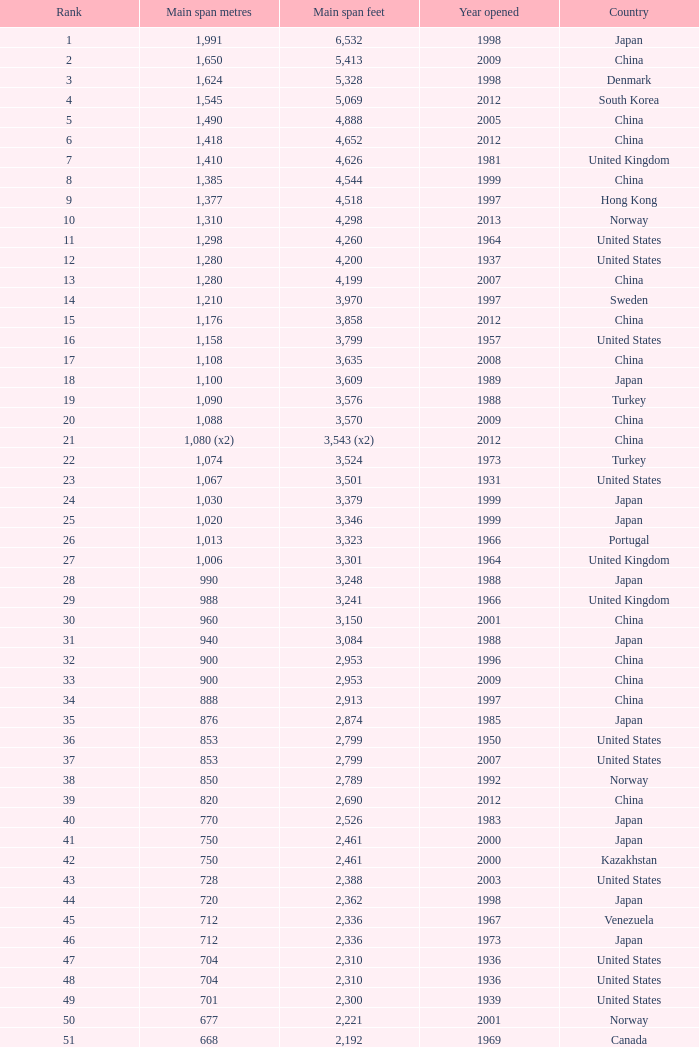What is the chief span in feet from a year of 2009 or newer with a rank under 94 and 1,310 main span meters? 4298.0. 